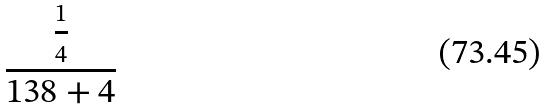<formula> <loc_0><loc_0><loc_500><loc_500>\frac { \frac { 1 } { 4 } } { 1 3 8 + 4 }</formula> 